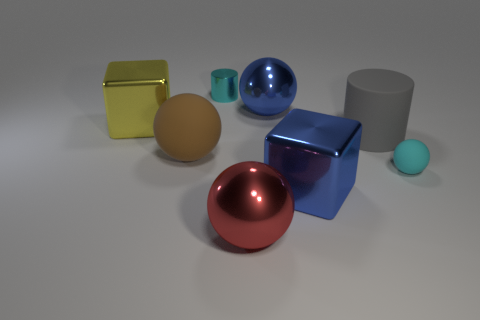There is another big thing that is the same shape as the large yellow thing; what is its material?
Offer a very short reply. Metal. Are there more cyan spheres than metallic blocks?
Give a very brief answer. No. There is a tiny ball; does it have the same color as the cylinder behind the large gray matte cylinder?
Your answer should be compact. Yes. What is the color of the large metal thing that is on the right side of the big yellow metal thing and behind the blue shiny block?
Give a very brief answer. Blue. What number of other things are there of the same material as the brown sphere
Provide a succinct answer. 2. Are there fewer gray cylinders than large gray rubber cubes?
Make the answer very short. No. Are the large cylinder and the cube in front of the cyan rubber thing made of the same material?
Your answer should be compact. No. What is the shape of the tiny object in front of the brown rubber ball?
Your answer should be compact. Sphere. Is there anything else that is the same color as the rubber cylinder?
Offer a very short reply. No. Are there fewer blue shiny cubes that are right of the red object than cyan matte things?
Offer a very short reply. No. 